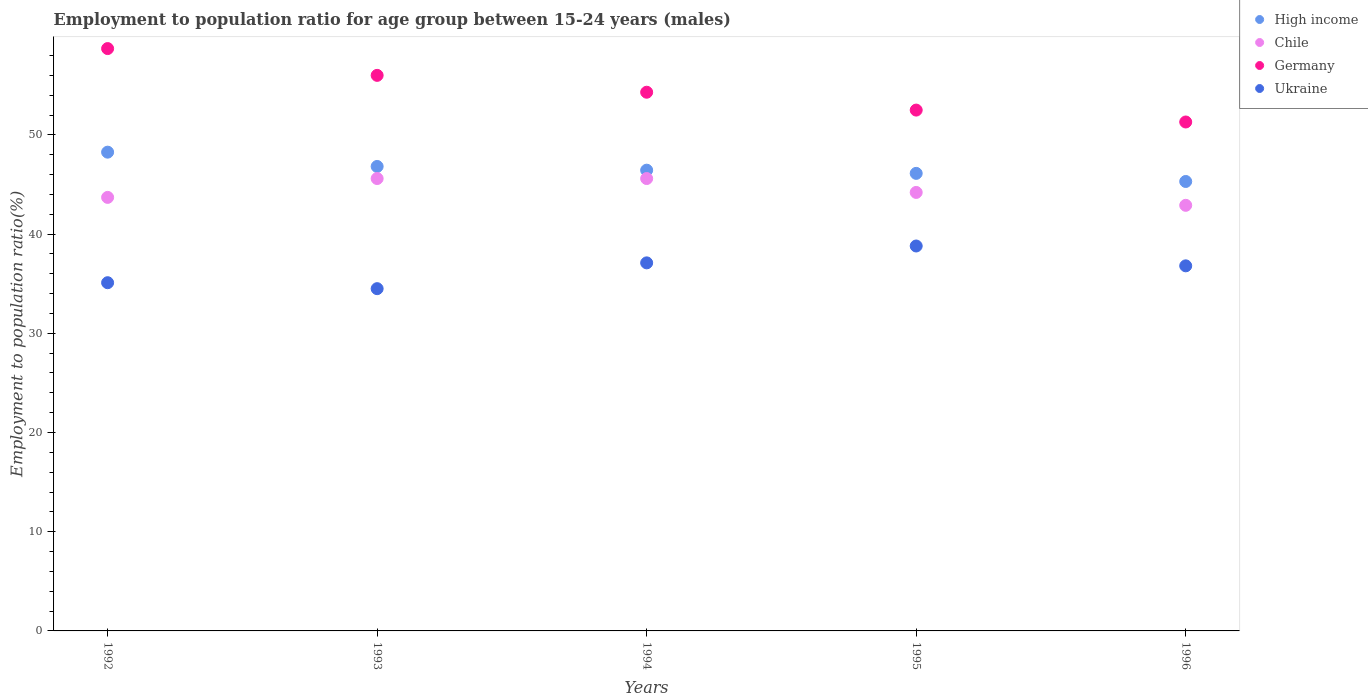How many different coloured dotlines are there?
Keep it short and to the point. 4. What is the employment to population ratio in High income in 1995?
Provide a succinct answer. 46.12. Across all years, what is the maximum employment to population ratio in Germany?
Give a very brief answer. 58.7. Across all years, what is the minimum employment to population ratio in Ukraine?
Your answer should be very brief. 34.5. What is the total employment to population ratio in Germany in the graph?
Your response must be concise. 272.8. What is the difference between the employment to population ratio in Germany in 1992 and that in 1993?
Give a very brief answer. 2.7. What is the difference between the employment to population ratio in Ukraine in 1994 and the employment to population ratio in Chile in 1996?
Provide a short and direct response. -5.8. What is the average employment to population ratio in Germany per year?
Offer a terse response. 54.56. In the year 1996, what is the difference between the employment to population ratio in Germany and employment to population ratio in Chile?
Give a very brief answer. 8.4. In how many years, is the employment to population ratio in Ukraine greater than 44 %?
Provide a succinct answer. 0. What is the ratio of the employment to population ratio in Germany in 1993 to that in 1994?
Your answer should be compact. 1.03. What is the difference between the highest and the second highest employment to population ratio in Ukraine?
Ensure brevity in your answer.  1.7. What is the difference between the highest and the lowest employment to population ratio in High income?
Keep it short and to the point. 2.96. Is the sum of the employment to population ratio in Ukraine in 1995 and 1996 greater than the maximum employment to population ratio in Germany across all years?
Your answer should be compact. Yes. Is it the case that in every year, the sum of the employment to population ratio in Germany and employment to population ratio in Chile  is greater than the sum of employment to population ratio in High income and employment to population ratio in Ukraine?
Make the answer very short. Yes. Is it the case that in every year, the sum of the employment to population ratio in High income and employment to population ratio in Germany  is greater than the employment to population ratio in Chile?
Your answer should be compact. Yes. How many years are there in the graph?
Provide a succinct answer. 5. What is the difference between two consecutive major ticks on the Y-axis?
Ensure brevity in your answer.  10. Does the graph contain any zero values?
Offer a terse response. No. How are the legend labels stacked?
Offer a terse response. Vertical. What is the title of the graph?
Ensure brevity in your answer.  Employment to population ratio for age group between 15-24 years (males). What is the label or title of the X-axis?
Ensure brevity in your answer.  Years. What is the label or title of the Y-axis?
Provide a succinct answer. Employment to population ratio(%). What is the Employment to population ratio(%) in High income in 1992?
Your response must be concise. 48.26. What is the Employment to population ratio(%) of Chile in 1992?
Offer a very short reply. 43.7. What is the Employment to population ratio(%) of Germany in 1992?
Provide a succinct answer. 58.7. What is the Employment to population ratio(%) in Ukraine in 1992?
Provide a short and direct response. 35.1. What is the Employment to population ratio(%) in High income in 1993?
Your answer should be very brief. 46.82. What is the Employment to population ratio(%) in Chile in 1993?
Provide a short and direct response. 45.6. What is the Employment to population ratio(%) of Germany in 1993?
Give a very brief answer. 56. What is the Employment to population ratio(%) in Ukraine in 1993?
Your response must be concise. 34.5. What is the Employment to population ratio(%) in High income in 1994?
Give a very brief answer. 46.44. What is the Employment to population ratio(%) of Chile in 1994?
Your answer should be compact. 45.6. What is the Employment to population ratio(%) in Germany in 1994?
Offer a terse response. 54.3. What is the Employment to population ratio(%) in Ukraine in 1994?
Your answer should be very brief. 37.1. What is the Employment to population ratio(%) in High income in 1995?
Provide a succinct answer. 46.12. What is the Employment to population ratio(%) of Chile in 1995?
Give a very brief answer. 44.2. What is the Employment to population ratio(%) of Germany in 1995?
Ensure brevity in your answer.  52.5. What is the Employment to population ratio(%) in Ukraine in 1995?
Provide a short and direct response. 38.8. What is the Employment to population ratio(%) in High income in 1996?
Provide a short and direct response. 45.3. What is the Employment to population ratio(%) of Chile in 1996?
Keep it short and to the point. 42.9. What is the Employment to population ratio(%) of Germany in 1996?
Make the answer very short. 51.3. What is the Employment to population ratio(%) of Ukraine in 1996?
Ensure brevity in your answer.  36.8. Across all years, what is the maximum Employment to population ratio(%) of High income?
Give a very brief answer. 48.26. Across all years, what is the maximum Employment to population ratio(%) of Chile?
Your response must be concise. 45.6. Across all years, what is the maximum Employment to population ratio(%) in Germany?
Provide a short and direct response. 58.7. Across all years, what is the maximum Employment to population ratio(%) in Ukraine?
Keep it short and to the point. 38.8. Across all years, what is the minimum Employment to population ratio(%) of High income?
Offer a very short reply. 45.3. Across all years, what is the minimum Employment to population ratio(%) in Chile?
Give a very brief answer. 42.9. Across all years, what is the minimum Employment to population ratio(%) in Germany?
Your response must be concise. 51.3. Across all years, what is the minimum Employment to population ratio(%) of Ukraine?
Your response must be concise. 34.5. What is the total Employment to population ratio(%) of High income in the graph?
Provide a short and direct response. 232.94. What is the total Employment to population ratio(%) of Chile in the graph?
Make the answer very short. 222. What is the total Employment to population ratio(%) of Germany in the graph?
Your response must be concise. 272.8. What is the total Employment to population ratio(%) in Ukraine in the graph?
Make the answer very short. 182.3. What is the difference between the Employment to population ratio(%) in High income in 1992 and that in 1993?
Make the answer very short. 1.44. What is the difference between the Employment to population ratio(%) of Ukraine in 1992 and that in 1993?
Keep it short and to the point. 0.6. What is the difference between the Employment to population ratio(%) of High income in 1992 and that in 1994?
Your answer should be very brief. 1.82. What is the difference between the Employment to population ratio(%) of Chile in 1992 and that in 1994?
Give a very brief answer. -1.9. What is the difference between the Employment to population ratio(%) in High income in 1992 and that in 1995?
Provide a succinct answer. 2.14. What is the difference between the Employment to population ratio(%) in Chile in 1992 and that in 1995?
Your response must be concise. -0.5. What is the difference between the Employment to population ratio(%) of Germany in 1992 and that in 1995?
Your response must be concise. 6.2. What is the difference between the Employment to population ratio(%) in High income in 1992 and that in 1996?
Provide a short and direct response. 2.96. What is the difference between the Employment to population ratio(%) of Chile in 1992 and that in 1996?
Give a very brief answer. 0.8. What is the difference between the Employment to population ratio(%) of Ukraine in 1992 and that in 1996?
Provide a succinct answer. -1.7. What is the difference between the Employment to population ratio(%) in High income in 1993 and that in 1994?
Provide a short and direct response. 0.38. What is the difference between the Employment to population ratio(%) in High income in 1993 and that in 1995?
Keep it short and to the point. 0.7. What is the difference between the Employment to population ratio(%) of Germany in 1993 and that in 1995?
Make the answer very short. 3.5. What is the difference between the Employment to population ratio(%) in Ukraine in 1993 and that in 1995?
Provide a succinct answer. -4.3. What is the difference between the Employment to population ratio(%) of High income in 1993 and that in 1996?
Provide a succinct answer. 1.51. What is the difference between the Employment to population ratio(%) of Germany in 1993 and that in 1996?
Your answer should be very brief. 4.7. What is the difference between the Employment to population ratio(%) in Ukraine in 1993 and that in 1996?
Give a very brief answer. -2.3. What is the difference between the Employment to population ratio(%) of High income in 1994 and that in 1995?
Offer a very short reply. 0.32. What is the difference between the Employment to population ratio(%) of Germany in 1994 and that in 1995?
Provide a succinct answer. 1.8. What is the difference between the Employment to population ratio(%) of Ukraine in 1994 and that in 1995?
Your answer should be compact. -1.7. What is the difference between the Employment to population ratio(%) in High income in 1994 and that in 1996?
Make the answer very short. 1.14. What is the difference between the Employment to population ratio(%) in Germany in 1994 and that in 1996?
Give a very brief answer. 3. What is the difference between the Employment to population ratio(%) of High income in 1995 and that in 1996?
Give a very brief answer. 0.82. What is the difference between the Employment to population ratio(%) in Chile in 1995 and that in 1996?
Offer a terse response. 1.3. What is the difference between the Employment to population ratio(%) in Ukraine in 1995 and that in 1996?
Offer a very short reply. 2. What is the difference between the Employment to population ratio(%) of High income in 1992 and the Employment to population ratio(%) of Chile in 1993?
Make the answer very short. 2.66. What is the difference between the Employment to population ratio(%) in High income in 1992 and the Employment to population ratio(%) in Germany in 1993?
Provide a short and direct response. -7.74. What is the difference between the Employment to population ratio(%) in High income in 1992 and the Employment to population ratio(%) in Ukraine in 1993?
Keep it short and to the point. 13.76. What is the difference between the Employment to population ratio(%) of Chile in 1992 and the Employment to population ratio(%) of Germany in 1993?
Ensure brevity in your answer.  -12.3. What is the difference between the Employment to population ratio(%) in Chile in 1992 and the Employment to population ratio(%) in Ukraine in 1993?
Your answer should be very brief. 9.2. What is the difference between the Employment to population ratio(%) of Germany in 1992 and the Employment to population ratio(%) of Ukraine in 1993?
Offer a very short reply. 24.2. What is the difference between the Employment to population ratio(%) of High income in 1992 and the Employment to population ratio(%) of Chile in 1994?
Your answer should be compact. 2.66. What is the difference between the Employment to population ratio(%) in High income in 1992 and the Employment to population ratio(%) in Germany in 1994?
Provide a succinct answer. -6.04. What is the difference between the Employment to population ratio(%) in High income in 1992 and the Employment to population ratio(%) in Ukraine in 1994?
Your response must be concise. 11.16. What is the difference between the Employment to population ratio(%) of Chile in 1992 and the Employment to population ratio(%) of Ukraine in 1994?
Provide a short and direct response. 6.6. What is the difference between the Employment to population ratio(%) in Germany in 1992 and the Employment to population ratio(%) in Ukraine in 1994?
Offer a very short reply. 21.6. What is the difference between the Employment to population ratio(%) of High income in 1992 and the Employment to population ratio(%) of Chile in 1995?
Provide a succinct answer. 4.06. What is the difference between the Employment to population ratio(%) of High income in 1992 and the Employment to population ratio(%) of Germany in 1995?
Offer a terse response. -4.24. What is the difference between the Employment to population ratio(%) in High income in 1992 and the Employment to population ratio(%) in Ukraine in 1995?
Offer a terse response. 9.46. What is the difference between the Employment to population ratio(%) of Chile in 1992 and the Employment to population ratio(%) of Ukraine in 1995?
Give a very brief answer. 4.9. What is the difference between the Employment to population ratio(%) in Germany in 1992 and the Employment to population ratio(%) in Ukraine in 1995?
Ensure brevity in your answer.  19.9. What is the difference between the Employment to population ratio(%) of High income in 1992 and the Employment to population ratio(%) of Chile in 1996?
Your response must be concise. 5.36. What is the difference between the Employment to population ratio(%) in High income in 1992 and the Employment to population ratio(%) in Germany in 1996?
Provide a short and direct response. -3.04. What is the difference between the Employment to population ratio(%) of High income in 1992 and the Employment to population ratio(%) of Ukraine in 1996?
Your response must be concise. 11.46. What is the difference between the Employment to population ratio(%) in Chile in 1992 and the Employment to population ratio(%) in Germany in 1996?
Your response must be concise. -7.6. What is the difference between the Employment to population ratio(%) of Chile in 1992 and the Employment to population ratio(%) of Ukraine in 1996?
Your response must be concise. 6.9. What is the difference between the Employment to population ratio(%) in Germany in 1992 and the Employment to population ratio(%) in Ukraine in 1996?
Your response must be concise. 21.9. What is the difference between the Employment to population ratio(%) in High income in 1993 and the Employment to population ratio(%) in Chile in 1994?
Your answer should be compact. 1.22. What is the difference between the Employment to population ratio(%) of High income in 1993 and the Employment to population ratio(%) of Germany in 1994?
Offer a very short reply. -7.48. What is the difference between the Employment to population ratio(%) of High income in 1993 and the Employment to population ratio(%) of Ukraine in 1994?
Provide a succinct answer. 9.72. What is the difference between the Employment to population ratio(%) of Germany in 1993 and the Employment to population ratio(%) of Ukraine in 1994?
Keep it short and to the point. 18.9. What is the difference between the Employment to population ratio(%) in High income in 1993 and the Employment to population ratio(%) in Chile in 1995?
Offer a terse response. 2.62. What is the difference between the Employment to population ratio(%) in High income in 1993 and the Employment to population ratio(%) in Germany in 1995?
Offer a very short reply. -5.68. What is the difference between the Employment to population ratio(%) of High income in 1993 and the Employment to population ratio(%) of Ukraine in 1995?
Provide a short and direct response. 8.02. What is the difference between the Employment to population ratio(%) of Chile in 1993 and the Employment to population ratio(%) of Germany in 1995?
Provide a succinct answer. -6.9. What is the difference between the Employment to population ratio(%) in Chile in 1993 and the Employment to population ratio(%) in Ukraine in 1995?
Keep it short and to the point. 6.8. What is the difference between the Employment to population ratio(%) in Germany in 1993 and the Employment to population ratio(%) in Ukraine in 1995?
Your answer should be very brief. 17.2. What is the difference between the Employment to population ratio(%) in High income in 1993 and the Employment to population ratio(%) in Chile in 1996?
Offer a terse response. 3.92. What is the difference between the Employment to population ratio(%) of High income in 1993 and the Employment to population ratio(%) of Germany in 1996?
Offer a very short reply. -4.48. What is the difference between the Employment to population ratio(%) of High income in 1993 and the Employment to population ratio(%) of Ukraine in 1996?
Keep it short and to the point. 10.02. What is the difference between the Employment to population ratio(%) of Chile in 1993 and the Employment to population ratio(%) of Germany in 1996?
Give a very brief answer. -5.7. What is the difference between the Employment to population ratio(%) of Chile in 1993 and the Employment to population ratio(%) of Ukraine in 1996?
Provide a short and direct response. 8.8. What is the difference between the Employment to population ratio(%) in High income in 1994 and the Employment to population ratio(%) in Chile in 1995?
Provide a succinct answer. 2.24. What is the difference between the Employment to population ratio(%) in High income in 1994 and the Employment to population ratio(%) in Germany in 1995?
Offer a terse response. -6.06. What is the difference between the Employment to population ratio(%) in High income in 1994 and the Employment to population ratio(%) in Ukraine in 1995?
Offer a very short reply. 7.64. What is the difference between the Employment to population ratio(%) of Chile in 1994 and the Employment to population ratio(%) of Germany in 1995?
Your answer should be compact. -6.9. What is the difference between the Employment to population ratio(%) in Chile in 1994 and the Employment to population ratio(%) in Ukraine in 1995?
Offer a terse response. 6.8. What is the difference between the Employment to population ratio(%) of Germany in 1994 and the Employment to population ratio(%) of Ukraine in 1995?
Ensure brevity in your answer.  15.5. What is the difference between the Employment to population ratio(%) of High income in 1994 and the Employment to population ratio(%) of Chile in 1996?
Your answer should be compact. 3.54. What is the difference between the Employment to population ratio(%) in High income in 1994 and the Employment to population ratio(%) in Germany in 1996?
Keep it short and to the point. -4.86. What is the difference between the Employment to population ratio(%) in High income in 1994 and the Employment to population ratio(%) in Ukraine in 1996?
Ensure brevity in your answer.  9.64. What is the difference between the Employment to population ratio(%) in Chile in 1994 and the Employment to population ratio(%) in Germany in 1996?
Give a very brief answer. -5.7. What is the difference between the Employment to population ratio(%) of High income in 1995 and the Employment to population ratio(%) of Chile in 1996?
Your response must be concise. 3.22. What is the difference between the Employment to population ratio(%) of High income in 1995 and the Employment to population ratio(%) of Germany in 1996?
Keep it short and to the point. -5.18. What is the difference between the Employment to population ratio(%) in High income in 1995 and the Employment to population ratio(%) in Ukraine in 1996?
Keep it short and to the point. 9.32. What is the difference between the Employment to population ratio(%) of Chile in 1995 and the Employment to population ratio(%) of Germany in 1996?
Your response must be concise. -7.1. What is the difference between the Employment to population ratio(%) in Chile in 1995 and the Employment to population ratio(%) in Ukraine in 1996?
Offer a terse response. 7.4. What is the difference between the Employment to population ratio(%) in Germany in 1995 and the Employment to population ratio(%) in Ukraine in 1996?
Make the answer very short. 15.7. What is the average Employment to population ratio(%) of High income per year?
Make the answer very short. 46.59. What is the average Employment to population ratio(%) in Chile per year?
Your response must be concise. 44.4. What is the average Employment to population ratio(%) in Germany per year?
Give a very brief answer. 54.56. What is the average Employment to population ratio(%) of Ukraine per year?
Ensure brevity in your answer.  36.46. In the year 1992, what is the difference between the Employment to population ratio(%) in High income and Employment to population ratio(%) in Chile?
Your response must be concise. 4.56. In the year 1992, what is the difference between the Employment to population ratio(%) in High income and Employment to population ratio(%) in Germany?
Your answer should be very brief. -10.44. In the year 1992, what is the difference between the Employment to population ratio(%) in High income and Employment to population ratio(%) in Ukraine?
Provide a succinct answer. 13.16. In the year 1992, what is the difference between the Employment to population ratio(%) in Chile and Employment to population ratio(%) in Germany?
Your answer should be very brief. -15. In the year 1992, what is the difference between the Employment to population ratio(%) of Chile and Employment to population ratio(%) of Ukraine?
Offer a terse response. 8.6. In the year 1992, what is the difference between the Employment to population ratio(%) in Germany and Employment to population ratio(%) in Ukraine?
Offer a terse response. 23.6. In the year 1993, what is the difference between the Employment to population ratio(%) in High income and Employment to population ratio(%) in Chile?
Give a very brief answer. 1.22. In the year 1993, what is the difference between the Employment to population ratio(%) in High income and Employment to population ratio(%) in Germany?
Give a very brief answer. -9.18. In the year 1993, what is the difference between the Employment to population ratio(%) of High income and Employment to population ratio(%) of Ukraine?
Make the answer very short. 12.32. In the year 1993, what is the difference between the Employment to population ratio(%) of Chile and Employment to population ratio(%) of Germany?
Keep it short and to the point. -10.4. In the year 1993, what is the difference between the Employment to population ratio(%) of Chile and Employment to population ratio(%) of Ukraine?
Offer a very short reply. 11.1. In the year 1993, what is the difference between the Employment to population ratio(%) in Germany and Employment to population ratio(%) in Ukraine?
Provide a succinct answer. 21.5. In the year 1994, what is the difference between the Employment to population ratio(%) in High income and Employment to population ratio(%) in Chile?
Keep it short and to the point. 0.84. In the year 1994, what is the difference between the Employment to population ratio(%) in High income and Employment to population ratio(%) in Germany?
Make the answer very short. -7.86. In the year 1994, what is the difference between the Employment to population ratio(%) in High income and Employment to population ratio(%) in Ukraine?
Keep it short and to the point. 9.34. In the year 1994, what is the difference between the Employment to population ratio(%) in Chile and Employment to population ratio(%) in Ukraine?
Your answer should be very brief. 8.5. In the year 1995, what is the difference between the Employment to population ratio(%) of High income and Employment to population ratio(%) of Chile?
Provide a succinct answer. 1.92. In the year 1995, what is the difference between the Employment to population ratio(%) in High income and Employment to population ratio(%) in Germany?
Give a very brief answer. -6.38. In the year 1995, what is the difference between the Employment to population ratio(%) in High income and Employment to population ratio(%) in Ukraine?
Ensure brevity in your answer.  7.32. In the year 1995, what is the difference between the Employment to population ratio(%) of Chile and Employment to population ratio(%) of Germany?
Offer a very short reply. -8.3. In the year 1995, what is the difference between the Employment to population ratio(%) of Germany and Employment to population ratio(%) of Ukraine?
Your answer should be very brief. 13.7. In the year 1996, what is the difference between the Employment to population ratio(%) of High income and Employment to population ratio(%) of Chile?
Ensure brevity in your answer.  2.4. In the year 1996, what is the difference between the Employment to population ratio(%) of High income and Employment to population ratio(%) of Germany?
Keep it short and to the point. -6. In the year 1996, what is the difference between the Employment to population ratio(%) of High income and Employment to population ratio(%) of Ukraine?
Your response must be concise. 8.5. In the year 1996, what is the difference between the Employment to population ratio(%) in Chile and Employment to population ratio(%) in Ukraine?
Offer a terse response. 6.1. What is the ratio of the Employment to population ratio(%) in High income in 1992 to that in 1993?
Make the answer very short. 1.03. What is the ratio of the Employment to population ratio(%) in Germany in 1992 to that in 1993?
Ensure brevity in your answer.  1.05. What is the ratio of the Employment to population ratio(%) of Ukraine in 1992 to that in 1993?
Your answer should be very brief. 1.02. What is the ratio of the Employment to population ratio(%) in High income in 1992 to that in 1994?
Give a very brief answer. 1.04. What is the ratio of the Employment to population ratio(%) in Chile in 1992 to that in 1994?
Ensure brevity in your answer.  0.96. What is the ratio of the Employment to population ratio(%) of Germany in 1992 to that in 1994?
Offer a very short reply. 1.08. What is the ratio of the Employment to population ratio(%) in Ukraine in 1992 to that in 1994?
Offer a very short reply. 0.95. What is the ratio of the Employment to population ratio(%) in High income in 1992 to that in 1995?
Your response must be concise. 1.05. What is the ratio of the Employment to population ratio(%) in Chile in 1992 to that in 1995?
Make the answer very short. 0.99. What is the ratio of the Employment to population ratio(%) in Germany in 1992 to that in 1995?
Give a very brief answer. 1.12. What is the ratio of the Employment to population ratio(%) in Ukraine in 1992 to that in 1995?
Provide a succinct answer. 0.9. What is the ratio of the Employment to population ratio(%) of High income in 1992 to that in 1996?
Your response must be concise. 1.07. What is the ratio of the Employment to population ratio(%) in Chile in 1992 to that in 1996?
Make the answer very short. 1.02. What is the ratio of the Employment to population ratio(%) in Germany in 1992 to that in 1996?
Your response must be concise. 1.14. What is the ratio of the Employment to population ratio(%) of Ukraine in 1992 to that in 1996?
Make the answer very short. 0.95. What is the ratio of the Employment to population ratio(%) in Chile in 1993 to that in 1994?
Offer a very short reply. 1. What is the ratio of the Employment to population ratio(%) in Germany in 1993 to that in 1994?
Provide a short and direct response. 1.03. What is the ratio of the Employment to population ratio(%) of Ukraine in 1993 to that in 1994?
Offer a very short reply. 0.93. What is the ratio of the Employment to population ratio(%) of High income in 1993 to that in 1995?
Ensure brevity in your answer.  1.02. What is the ratio of the Employment to population ratio(%) in Chile in 1993 to that in 1995?
Offer a very short reply. 1.03. What is the ratio of the Employment to population ratio(%) of Germany in 1993 to that in 1995?
Provide a succinct answer. 1.07. What is the ratio of the Employment to population ratio(%) in Ukraine in 1993 to that in 1995?
Your answer should be compact. 0.89. What is the ratio of the Employment to population ratio(%) of High income in 1993 to that in 1996?
Your answer should be compact. 1.03. What is the ratio of the Employment to population ratio(%) of Chile in 1993 to that in 1996?
Provide a succinct answer. 1.06. What is the ratio of the Employment to population ratio(%) in Germany in 1993 to that in 1996?
Offer a terse response. 1.09. What is the ratio of the Employment to population ratio(%) of Chile in 1994 to that in 1995?
Your response must be concise. 1.03. What is the ratio of the Employment to population ratio(%) of Germany in 1994 to that in 1995?
Offer a terse response. 1.03. What is the ratio of the Employment to population ratio(%) in Ukraine in 1994 to that in 1995?
Offer a terse response. 0.96. What is the ratio of the Employment to population ratio(%) of High income in 1994 to that in 1996?
Your response must be concise. 1.03. What is the ratio of the Employment to population ratio(%) of Chile in 1994 to that in 1996?
Offer a very short reply. 1.06. What is the ratio of the Employment to population ratio(%) in Germany in 1994 to that in 1996?
Your response must be concise. 1.06. What is the ratio of the Employment to population ratio(%) of Ukraine in 1994 to that in 1996?
Provide a succinct answer. 1.01. What is the ratio of the Employment to population ratio(%) in Chile in 1995 to that in 1996?
Offer a very short reply. 1.03. What is the ratio of the Employment to population ratio(%) in Germany in 1995 to that in 1996?
Make the answer very short. 1.02. What is the ratio of the Employment to population ratio(%) in Ukraine in 1995 to that in 1996?
Your answer should be compact. 1.05. What is the difference between the highest and the second highest Employment to population ratio(%) of High income?
Your response must be concise. 1.44. What is the difference between the highest and the second highest Employment to population ratio(%) of Germany?
Ensure brevity in your answer.  2.7. What is the difference between the highest and the second highest Employment to population ratio(%) of Ukraine?
Give a very brief answer. 1.7. What is the difference between the highest and the lowest Employment to population ratio(%) of High income?
Offer a very short reply. 2.96. 